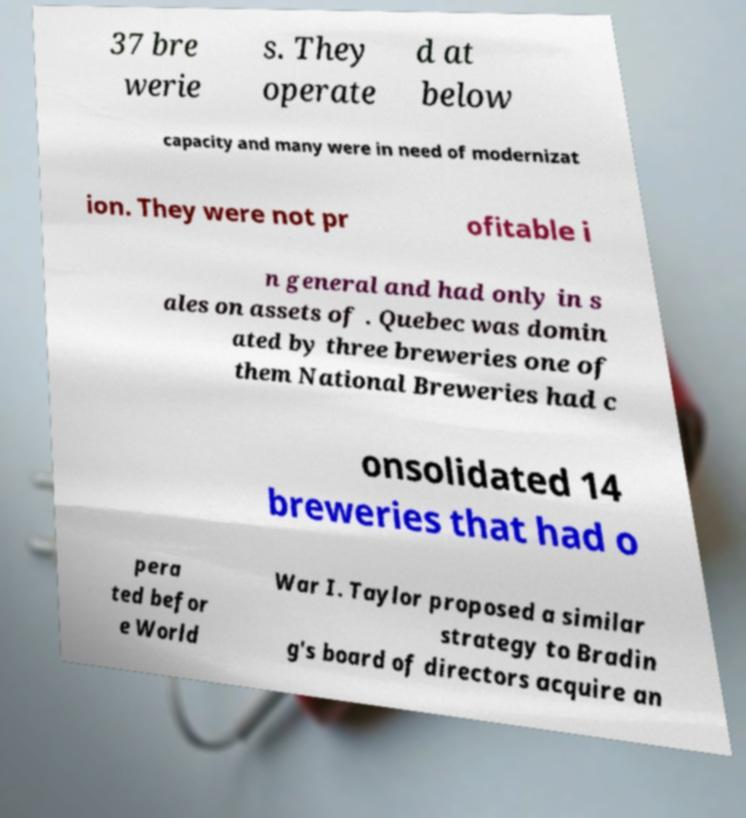Please read and relay the text visible in this image. What does it say? 37 bre werie s. They operate d at below capacity and many were in need of modernizat ion. They were not pr ofitable i n general and had only in s ales on assets of . Quebec was domin ated by three breweries one of them National Breweries had c onsolidated 14 breweries that had o pera ted befor e World War I. Taylor proposed a similar strategy to Bradin g's board of directors acquire an 